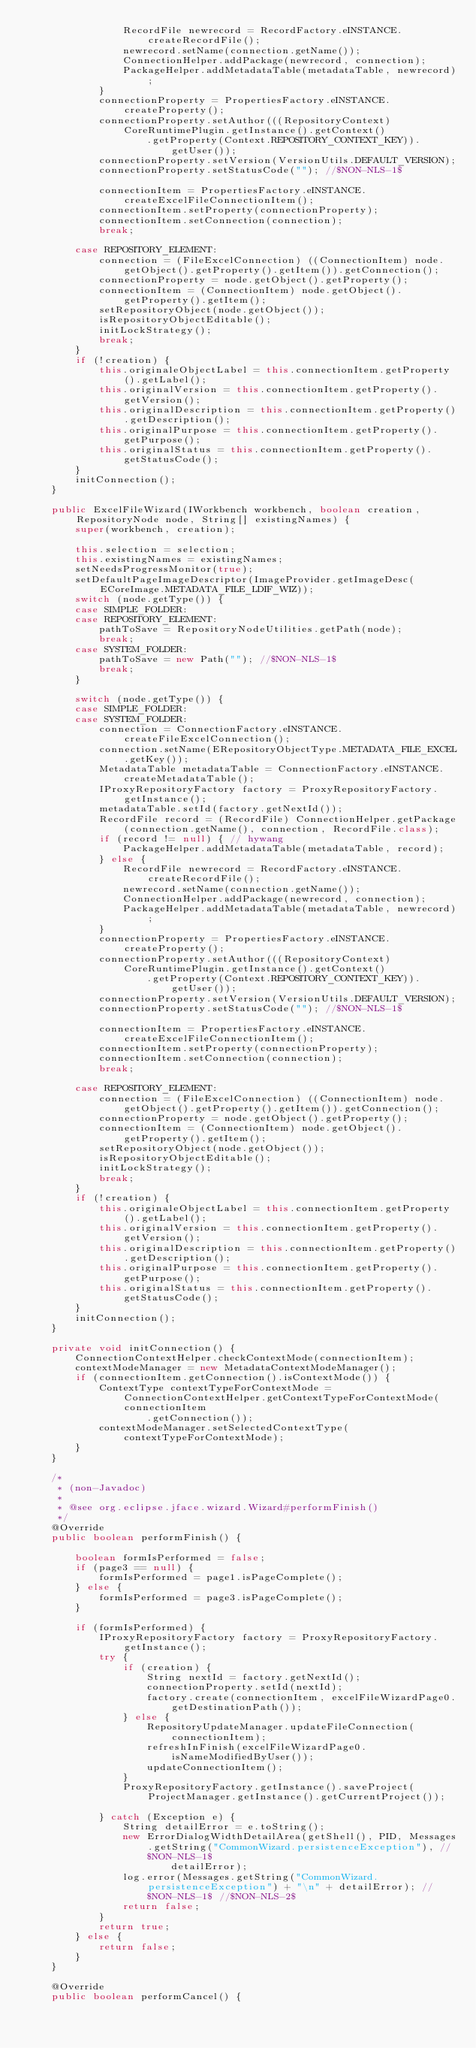<code> <loc_0><loc_0><loc_500><loc_500><_Java_>                RecordFile newrecord = RecordFactory.eINSTANCE.createRecordFile();
                newrecord.setName(connection.getName());
                ConnectionHelper.addPackage(newrecord, connection);
                PackageHelper.addMetadataTable(metadataTable, newrecord);
            }
            connectionProperty = PropertiesFactory.eINSTANCE.createProperty();
            connectionProperty.setAuthor(((RepositoryContext) CoreRuntimePlugin.getInstance().getContext()
                    .getProperty(Context.REPOSITORY_CONTEXT_KEY)).getUser());
            connectionProperty.setVersion(VersionUtils.DEFAULT_VERSION);
            connectionProperty.setStatusCode(""); //$NON-NLS-1$

            connectionItem = PropertiesFactory.eINSTANCE.createExcelFileConnectionItem();
            connectionItem.setProperty(connectionProperty);
            connectionItem.setConnection(connection);
            break;

        case REPOSITORY_ELEMENT:
            connection = (FileExcelConnection) ((ConnectionItem) node.getObject().getProperty().getItem()).getConnection();
            connectionProperty = node.getObject().getProperty();
            connectionItem = (ConnectionItem) node.getObject().getProperty().getItem();
            setRepositoryObject(node.getObject());
            isRepositoryObjectEditable();
            initLockStrategy();
            break;
        }
        if (!creation) {
            this.originaleObjectLabel = this.connectionItem.getProperty().getLabel();
            this.originalVersion = this.connectionItem.getProperty().getVersion();
            this.originalDescription = this.connectionItem.getProperty().getDescription();
            this.originalPurpose = this.connectionItem.getProperty().getPurpose();
            this.originalStatus = this.connectionItem.getProperty().getStatusCode();
        }
        initConnection();
    }

    public ExcelFileWizard(IWorkbench workbench, boolean creation, RepositoryNode node, String[] existingNames) {
        super(workbench, creation);

        this.selection = selection;
        this.existingNames = existingNames;
        setNeedsProgressMonitor(true);
        setDefaultPageImageDescriptor(ImageProvider.getImageDesc(ECoreImage.METADATA_FILE_LDIF_WIZ));
        switch (node.getType()) {
        case SIMPLE_FOLDER:
        case REPOSITORY_ELEMENT:
            pathToSave = RepositoryNodeUtilities.getPath(node);
            break;
        case SYSTEM_FOLDER:
            pathToSave = new Path(""); //$NON-NLS-1$
            break;
        }

        switch (node.getType()) {
        case SIMPLE_FOLDER:
        case SYSTEM_FOLDER:
            connection = ConnectionFactory.eINSTANCE.createFileExcelConnection();
            connection.setName(ERepositoryObjectType.METADATA_FILE_EXCEL.getKey());
            MetadataTable metadataTable = ConnectionFactory.eINSTANCE.createMetadataTable();
            IProxyRepositoryFactory factory = ProxyRepositoryFactory.getInstance();
            metadataTable.setId(factory.getNextId());
            RecordFile record = (RecordFile) ConnectionHelper.getPackage(connection.getName(), connection, RecordFile.class);
            if (record != null) { // hywang
                PackageHelper.addMetadataTable(metadataTable, record);
            } else {
                RecordFile newrecord = RecordFactory.eINSTANCE.createRecordFile();
                newrecord.setName(connection.getName());
                ConnectionHelper.addPackage(newrecord, connection);
                PackageHelper.addMetadataTable(metadataTable, newrecord);
            }
            connectionProperty = PropertiesFactory.eINSTANCE.createProperty();
            connectionProperty.setAuthor(((RepositoryContext) CoreRuntimePlugin.getInstance().getContext()
                    .getProperty(Context.REPOSITORY_CONTEXT_KEY)).getUser());
            connectionProperty.setVersion(VersionUtils.DEFAULT_VERSION);
            connectionProperty.setStatusCode(""); //$NON-NLS-1$

            connectionItem = PropertiesFactory.eINSTANCE.createExcelFileConnectionItem();
            connectionItem.setProperty(connectionProperty);
            connectionItem.setConnection(connection);
            break;

        case REPOSITORY_ELEMENT:
            connection = (FileExcelConnection) ((ConnectionItem) node.getObject().getProperty().getItem()).getConnection();
            connectionProperty = node.getObject().getProperty();
            connectionItem = (ConnectionItem) node.getObject().getProperty().getItem();
            setRepositoryObject(node.getObject());
            isRepositoryObjectEditable();
            initLockStrategy();
            break;
        }
        if (!creation) {
            this.originaleObjectLabel = this.connectionItem.getProperty().getLabel();
            this.originalVersion = this.connectionItem.getProperty().getVersion();
            this.originalDescription = this.connectionItem.getProperty().getDescription();
            this.originalPurpose = this.connectionItem.getProperty().getPurpose();
            this.originalStatus = this.connectionItem.getProperty().getStatusCode();
        }
        initConnection();
    }

    private void initConnection() {
        ConnectionContextHelper.checkContextMode(connectionItem);
        contextModeManager = new MetadataContextModeManager();
        if (connectionItem.getConnection().isContextMode()) {
            ContextType contextTypeForContextMode = ConnectionContextHelper.getContextTypeForContextMode(connectionItem
                    .getConnection());
            contextModeManager.setSelectedContextType(contextTypeForContextMode);
        }
    }

    /*
     * (non-Javadoc)
     * 
     * @see org.eclipse.jface.wizard.Wizard#performFinish()
     */
    @Override
    public boolean performFinish() {

        boolean formIsPerformed = false;
        if (page3 == null) {
            formIsPerformed = page1.isPageComplete();
        } else {
            formIsPerformed = page3.isPageComplete();
        }

        if (formIsPerformed) {
            IProxyRepositoryFactory factory = ProxyRepositoryFactory.getInstance();
            try {
                if (creation) {
                    String nextId = factory.getNextId();
                    connectionProperty.setId(nextId);
                    factory.create(connectionItem, excelFileWizardPage0.getDestinationPath());
                } else {
                    RepositoryUpdateManager.updateFileConnection(connectionItem);
                    refreshInFinish(excelFileWizardPage0.isNameModifiedByUser());
                    updateConnectionItem();
                }
                ProxyRepositoryFactory.getInstance().saveProject(ProjectManager.getInstance().getCurrentProject());

            } catch (Exception e) {
                String detailError = e.toString();
                new ErrorDialogWidthDetailArea(getShell(), PID, Messages.getString("CommonWizard.persistenceException"), //$NON-NLS-1$
                        detailError);
                log.error(Messages.getString("CommonWizard.persistenceException") + "\n" + detailError); //$NON-NLS-1$ //$NON-NLS-2$
                return false;
            }
            return true;
        } else {
            return false;
        }
    }

    @Override
    public boolean performCancel() {</code> 